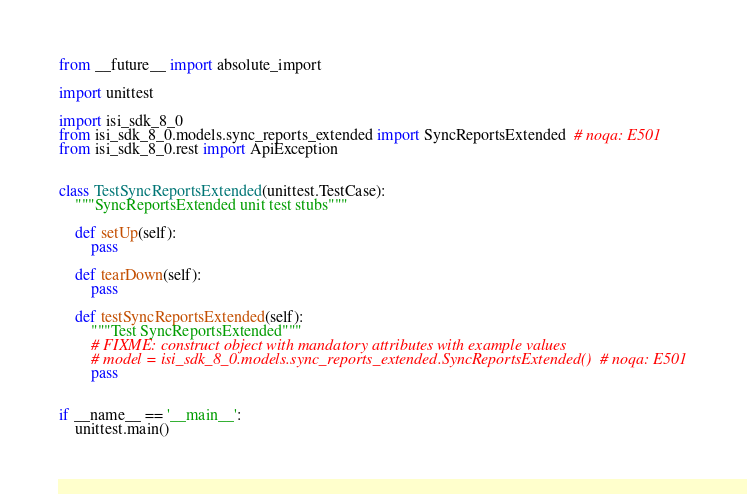Convert code to text. <code><loc_0><loc_0><loc_500><loc_500><_Python_>from __future__ import absolute_import

import unittest

import isi_sdk_8_0
from isi_sdk_8_0.models.sync_reports_extended import SyncReportsExtended  # noqa: E501
from isi_sdk_8_0.rest import ApiException


class TestSyncReportsExtended(unittest.TestCase):
    """SyncReportsExtended unit test stubs"""

    def setUp(self):
        pass

    def tearDown(self):
        pass

    def testSyncReportsExtended(self):
        """Test SyncReportsExtended"""
        # FIXME: construct object with mandatory attributes with example values
        # model = isi_sdk_8_0.models.sync_reports_extended.SyncReportsExtended()  # noqa: E501
        pass


if __name__ == '__main__':
    unittest.main()
</code> 